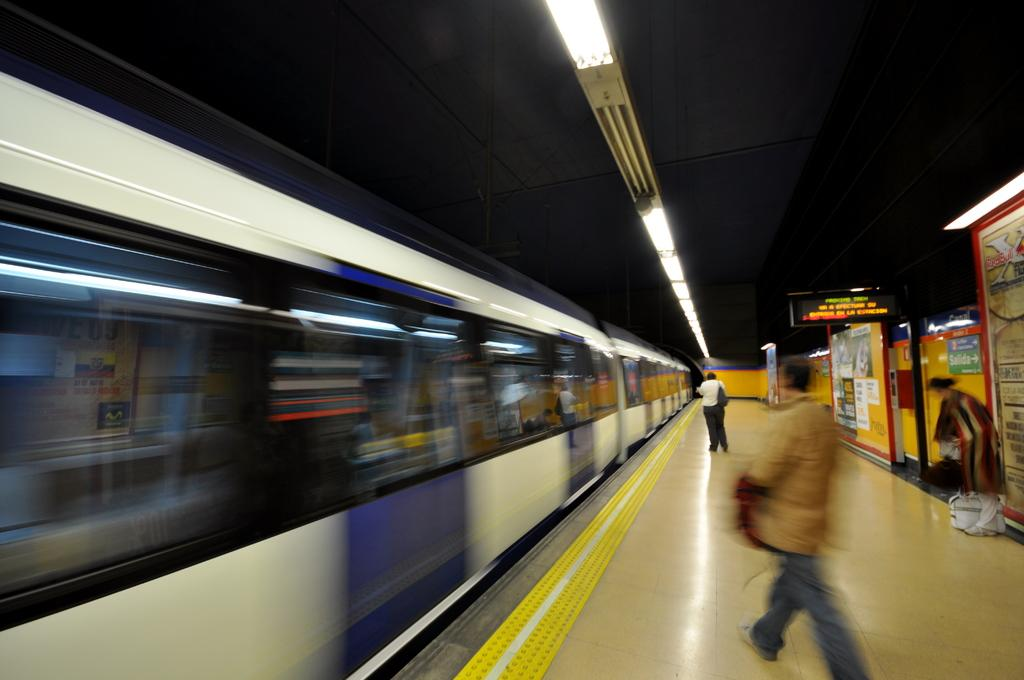What is located on the left side of the image? There is a train on the left side of the image. What can be seen at the top of the image? There is a ceiling with lights at the top of the image. What are the people in the image doing? People are walking to the right side of the image. How many pizzas are being carried by the geese in the image? There are no geese or pizzas present in the image. Is there a volcano erupting in the background of the image? There is no volcano present in the image. 